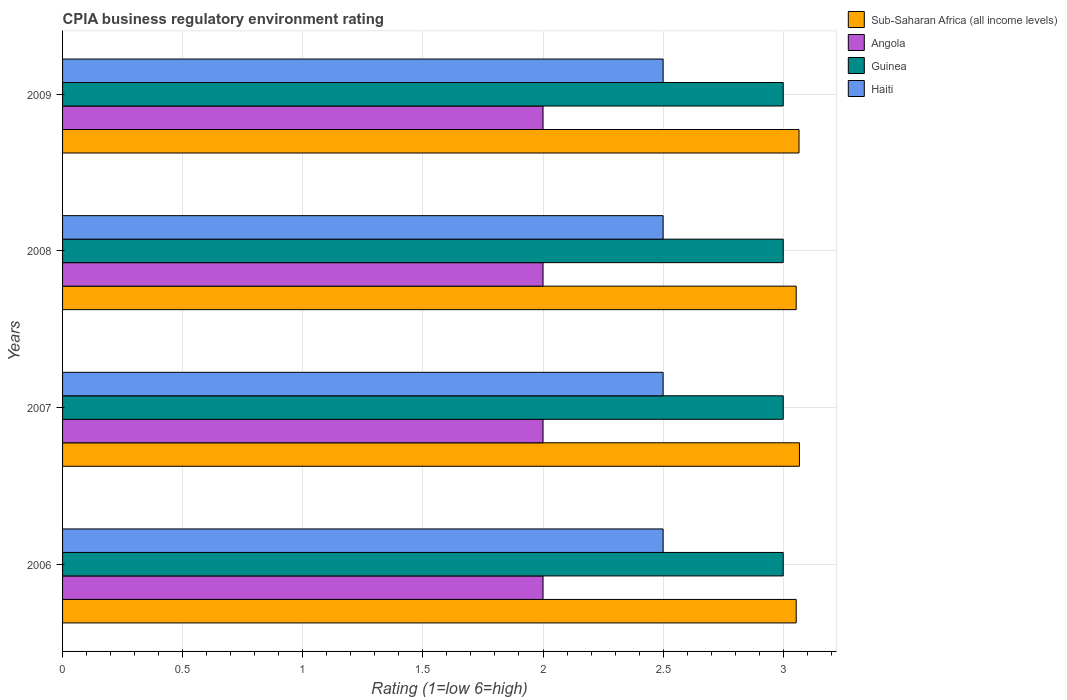Are the number of bars per tick equal to the number of legend labels?
Provide a succinct answer. Yes. How many bars are there on the 3rd tick from the top?
Ensure brevity in your answer.  4. How many bars are there on the 1st tick from the bottom?
Your answer should be very brief. 4. What is the CPIA rating in Guinea in 2006?
Provide a short and direct response. 3. Across all years, what is the minimum CPIA rating in Sub-Saharan Africa (all income levels)?
Your response must be concise. 3.05. In which year was the CPIA rating in Angola minimum?
Keep it short and to the point. 2006. What is the total CPIA rating in Sub-Saharan Africa (all income levels) in the graph?
Your answer should be compact. 12.24. What is the average CPIA rating in Guinea per year?
Provide a short and direct response. 3. In the year 2008, what is the difference between the CPIA rating in Haiti and CPIA rating in Angola?
Provide a short and direct response. 0.5. In how many years, is the CPIA rating in Sub-Saharan Africa (all income levels) greater than 2 ?
Provide a short and direct response. 4. What is the ratio of the CPIA rating in Guinea in 2008 to that in 2009?
Make the answer very short. 1. What is the difference between the highest and the second highest CPIA rating in Haiti?
Offer a very short reply. 0. In how many years, is the CPIA rating in Guinea greater than the average CPIA rating in Guinea taken over all years?
Make the answer very short. 0. Is the sum of the CPIA rating in Guinea in 2006 and 2008 greater than the maximum CPIA rating in Angola across all years?
Offer a terse response. Yes. Is it the case that in every year, the sum of the CPIA rating in Angola and CPIA rating in Guinea is greater than the sum of CPIA rating in Sub-Saharan Africa (all income levels) and CPIA rating in Haiti?
Provide a short and direct response. Yes. What does the 1st bar from the top in 2006 represents?
Ensure brevity in your answer.  Haiti. What does the 3rd bar from the bottom in 2006 represents?
Keep it short and to the point. Guinea. Are all the bars in the graph horizontal?
Provide a succinct answer. Yes. How many years are there in the graph?
Offer a terse response. 4. Are the values on the major ticks of X-axis written in scientific E-notation?
Your answer should be very brief. No. Does the graph contain any zero values?
Offer a very short reply. No. Does the graph contain grids?
Give a very brief answer. Yes. What is the title of the graph?
Your answer should be compact. CPIA business regulatory environment rating. What is the label or title of the X-axis?
Keep it short and to the point. Rating (1=low 6=high). What is the label or title of the Y-axis?
Make the answer very short. Years. What is the Rating (1=low 6=high) of Sub-Saharan Africa (all income levels) in 2006?
Keep it short and to the point. 3.05. What is the Rating (1=low 6=high) of Angola in 2006?
Give a very brief answer. 2. What is the Rating (1=low 6=high) in Guinea in 2006?
Your answer should be compact. 3. What is the Rating (1=low 6=high) of Sub-Saharan Africa (all income levels) in 2007?
Your response must be concise. 3.07. What is the Rating (1=low 6=high) of Angola in 2007?
Your answer should be compact. 2. What is the Rating (1=low 6=high) in Guinea in 2007?
Your response must be concise. 3. What is the Rating (1=low 6=high) in Sub-Saharan Africa (all income levels) in 2008?
Your answer should be very brief. 3.05. What is the Rating (1=low 6=high) in Guinea in 2008?
Offer a very short reply. 3. What is the Rating (1=low 6=high) in Sub-Saharan Africa (all income levels) in 2009?
Make the answer very short. 3.07. What is the Rating (1=low 6=high) in Guinea in 2009?
Give a very brief answer. 3. Across all years, what is the maximum Rating (1=low 6=high) in Sub-Saharan Africa (all income levels)?
Make the answer very short. 3.07. Across all years, what is the maximum Rating (1=low 6=high) in Angola?
Your answer should be very brief. 2. Across all years, what is the maximum Rating (1=low 6=high) of Haiti?
Offer a terse response. 2.5. Across all years, what is the minimum Rating (1=low 6=high) of Sub-Saharan Africa (all income levels)?
Provide a succinct answer. 3.05. Across all years, what is the minimum Rating (1=low 6=high) of Angola?
Ensure brevity in your answer.  2. Across all years, what is the minimum Rating (1=low 6=high) of Guinea?
Offer a very short reply. 3. What is the total Rating (1=low 6=high) of Sub-Saharan Africa (all income levels) in the graph?
Your answer should be compact. 12.24. What is the total Rating (1=low 6=high) of Angola in the graph?
Your answer should be very brief. 8. What is the total Rating (1=low 6=high) in Guinea in the graph?
Offer a terse response. 12. What is the total Rating (1=low 6=high) in Haiti in the graph?
Ensure brevity in your answer.  10. What is the difference between the Rating (1=low 6=high) in Sub-Saharan Africa (all income levels) in 2006 and that in 2007?
Your answer should be compact. -0.01. What is the difference between the Rating (1=low 6=high) in Angola in 2006 and that in 2007?
Offer a terse response. 0. What is the difference between the Rating (1=low 6=high) of Guinea in 2006 and that in 2007?
Your answer should be very brief. 0. What is the difference between the Rating (1=low 6=high) in Haiti in 2006 and that in 2007?
Provide a short and direct response. 0. What is the difference between the Rating (1=low 6=high) in Sub-Saharan Africa (all income levels) in 2006 and that in 2008?
Make the answer very short. 0. What is the difference between the Rating (1=low 6=high) of Guinea in 2006 and that in 2008?
Your response must be concise. 0. What is the difference between the Rating (1=low 6=high) of Sub-Saharan Africa (all income levels) in 2006 and that in 2009?
Your answer should be compact. -0.01. What is the difference between the Rating (1=low 6=high) in Guinea in 2006 and that in 2009?
Provide a short and direct response. 0. What is the difference between the Rating (1=low 6=high) in Sub-Saharan Africa (all income levels) in 2007 and that in 2008?
Provide a short and direct response. 0.01. What is the difference between the Rating (1=low 6=high) in Angola in 2007 and that in 2008?
Offer a very short reply. 0. What is the difference between the Rating (1=low 6=high) in Haiti in 2007 and that in 2008?
Ensure brevity in your answer.  0. What is the difference between the Rating (1=low 6=high) of Sub-Saharan Africa (all income levels) in 2007 and that in 2009?
Ensure brevity in your answer.  0. What is the difference between the Rating (1=low 6=high) in Sub-Saharan Africa (all income levels) in 2008 and that in 2009?
Your answer should be compact. -0.01. What is the difference between the Rating (1=low 6=high) of Angola in 2008 and that in 2009?
Give a very brief answer. 0. What is the difference between the Rating (1=low 6=high) in Guinea in 2008 and that in 2009?
Provide a short and direct response. 0. What is the difference between the Rating (1=low 6=high) of Haiti in 2008 and that in 2009?
Make the answer very short. 0. What is the difference between the Rating (1=low 6=high) in Sub-Saharan Africa (all income levels) in 2006 and the Rating (1=low 6=high) in Angola in 2007?
Your answer should be very brief. 1.05. What is the difference between the Rating (1=low 6=high) in Sub-Saharan Africa (all income levels) in 2006 and the Rating (1=low 6=high) in Guinea in 2007?
Your answer should be compact. 0.05. What is the difference between the Rating (1=low 6=high) of Sub-Saharan Africa (all income levels) in 2006 and the Rating (1=low 6=high) of Haiti in 2007?
Your answer should be very brief. 0.55. What is the difference between the Rating (1=low 6=high) in Angola in 2006 and the Rating (1=low 6=high) in Guinea in 2007?
Your answer should be very brief. -1. What is the difference between the Rating (1=low 6=high) in Guinea in 2006 and the Rating (1=low 6=high) in Haiti in 2007?
Your answer should be compact. 0.5. What is the difference between the Rating (1=low 6=high) in Sub-Saharan Africa (all income levels) in 2006 and the Rating (1=low 6=high) in Angola in 2008?
Provide a succinct answer. 1.05. What is the difference between the Rating (1=low 6=high) in Sub-Saharan Africa (all income levels) in 2006 and the Rating (1=low 6=high) in Guinea in 2008?
Ensure brevity in your answer.  0.05. What is the difference between the Rating (1=low 6=high) in Sub-Saharan Africa (all income levels) in 2006 and the Rating (1=low 6=high) in Haiti in 2008?
Provide a succinct answer. 0.55. What is the difference between the Rating (1=low 6=high) of Angola in 2006 and the Rating (1=low 6=high) of Guinea in 2008?
Your response must be concise. -1. What is the difference between the Rating (1=low 6=high) in Sub-Saharan Africa (all income levels) in 2006 and the Rating (1=low 6=high) in Angola in 2009?
Provide a succinct answer. 1.05. What is the difference between the Rating (1=low 6=high) of Sub-Saharan Africa (all income levels) in 2006 and the Rating (1=low 6=high) of Guinea in 2009?
Your answer should be compact. 0.05. What is the difference between the Rating (1=low 6=high) in Sub-Saharan Africa (all income levels) in 2006 and the Rating (1=low 6=high) in Haiti in 2009?
Make the answer very short. 0.55. What is the difference between the Rating (1=low 6=high) of Sub-Saharan Africa (all income levels) in 2007 and the Rating (1=low 6=high) of Angola in 2008?
Your response must be concise. 1.07. What is the difference between the Rating (1=low 6=high) of Sub-Saharan Africa (all income levels) in 2007 and the Rating (1=low 6=high) of Guinea in 2008?
Keep it short and to the point. 0.07. What is the difference between the Rating (1=low 6=high) in Sub-Saharan Africa (all income levels) in 2007 and the Rating (1=low 6=high) in Haiti in 2008?
Ensure brevity in your answer.  0.57. What is the difference between the Rating (1=low 6=high) in Sub-Saharan Africa (all income levels) in 2007 and the Rating (1=low 6=high) in Angola in 2009?
Give a very brief answer. 1.07. What is the difference between the Rating (1=low 6=high) in Sub-Saharan Africa (all income levels) in 2007 and the Rating (1=low 6=high) in Guinea in 2009?
Your response must be concise. 0.07. What is the difference between the Rating (1=low 6=high) of Sub-Saharan Africa (all income levels) in 2007 and the Rating (1=low 6=high) of Haiti in 2009?
Your answer should be compact. 0.57. What is the difference between the Rating (1=low 6=high) of Angola in 2007 and the Rating (1=low 6=high) of Haiti in 2009?
Provide a succinct answer. -0.5. What is the difference between the Rating (1=low 6=high) of Guinea in 2007 and the Rating (1=low 6=high) of Haiti in 2009?
Offer a terse response. 0.5. What is the difference between the Rating (1=low 6=high) of Sub-Saharan Africa (all income levels) in 2008 and the Rating (1=low 6=high) of Angola in 2009?
Your answer should be compact. 1.05. What is the difference between the Rating (1=low 6=high) of Sub-Saharan Africa (all income levels) in 2008 and the Rating (1=low 6=high) of Guinea in 2009?
Your answer should be very brief. 0.05. What is the difference between the Rating (1=low 6=high) in Sub-Saharan Africa (all income levels) in 2008 and the Rating (1=low 6=high) in Haiti in 2009?
Offer a very short reply. 0.55. What is the difference between the Rating (1=low 6=high) of Angola in 2008 and the Rating (1=low 6=high) of Guinea in 2009?
Provide a succinct answer. -1. What is the difference between the Rating (1=low 6=high) in Guinea in 2008 and the Rating (1=low 6=high) in Haiti in 2009?
Offer a very short reply. 0.5. What is the average Rating (1=low 6=high) in Sub-Saharan Africa (all income levels) per year?
Your response must be concise. 3.06. What is the average Rating (1=low 6=high) of Guinea per year?
Offer a terse response. 3. In the year 2006, what is the difference between the Rating (1=low 6=high) in Sub-Saharan Africa (all income levels) and Rating (1=low 6=high) in Angola?
Ensure brevity in your answer.  1.05. In the year 2006, what is the difference between the Rating (1=low 6=high) of Sub-Saharan Africa (all income levels) and Rating (1=low 6=high) of Guinea?
Provide a short and direct response. 0.05. In the year 2006, what is the difference between the Rating (1=low 6=high) in Sub-Saharan Africa (all income levels) and Rating (1=low 6=high) in Haiti?
Provide a succinct answer. 0.55. In the year 2006, what is the difference between the Rating (1=low 6=high) of Angola and Rating (1=low 6=high) of Guinea?
Make the answer very short. -1. In the year 2006, what is the difference between the Rating (1=low 6=high) in Guinea and Rating (1=low 6=high) in Haiti?
Your answer should be very brief. 0.5. In the year 2007, what is the difference between the Rating (1=low 6=high) in Sub-Saharan Africa (all income levels) and Rating (1=low 6=high) in Angola?
Offer a very short reply. 1.07. In the year 2007, what is the difference between the Rating (1=low 6=high) in Sub-Saharan Africa (all income levels) and Rating (1=low 6=high) in Guinea?
Give a very brief answer. 0.07. In the year 2007, what is the difference between the Rating (1=low 6=high) of Sub-Saharan Africa (all income levels) and Rating (1=low 6=high) of Haiti?
Give a very brief answer. 0.57. In the year 2008, what is the difference between the Rating (1=low 6=high) in Sub-Saharan Africa (all income levels) and Rating (1=low 6=high) in Angola?
Your answer should be very brief. 1.05. In the year 2008, what is the difference between the Rating (1=low 6=high) in Sub-Saharan Africa (all income levels) and Rating (1=low 6=high) in Guinea?
Provide a succinct answer. 0.05. In the year 2008, what is the difference between the Rating (1=low 6=high) in Sub-Saharan Africa (all income levels) and Rating (1=low 6=high) in Haiti?
Make the answer very short. 0.55. In the year 2008, what is the difference between the Rating (1=low 6=high) in Angola and Rating (1=low 6=high) in Guinea?
Your response must be concise. -1. In the year 2008, what is the difference between the Rating (1=low 6=high) of Angola and Rating (1=low 6=high) of Haiti?
Offer a terse response. -0.5. In the year 2008, what is the difference between the Rating (1=low 6=high) of Guinea and Rating (1=low 6=high) of Haiti?
Offer a very short reply. 0.5. In the year 2009, what is the difference between the Rating (1=low 6=high) in Sub-Saharan Africa (all income levels) and Rating (1=low 6=high) in Angola?
Your answer should be compact. 1.07. In the year 2009, what is the difference between the Rating (1=low 6=high) of Sub-Saharan Africa (all income levels) and Rating (1=low 6=high) of Guinea?
Your answer should be very brief. 0.07. In the year 2009, what is the difference between the Rating (1=low 6=high) of Sub-Saharan Africa (all income levels) and Rating (1=low 6=high) of Haiti?
Offer a very short reply. 0.57. In the year 2009, what is the difference between the Rating (1=low 6=high) in Angola and Rating (1=low 6=high) in Guinea?
Ensure brevity in your answer.  -1. In the year 2009, what is the difference between the Rating (1=low 6=high) in Angola and Rating (1=low 6=high) in Haiti?
Ensure brevity in your answer.  -0.5. What is the ratio of the Rating (1=low 6=high) of Guinea in 2006 to that in 2007?
Offer a very short reply. 1. What is the ratio of the Rating (1=low 6=high) of Haiti in 2006 to that in 2007?
Keep it short and to the point. 1. What is the ratio of the Rating (1=low 6=high) in Sub-Saharan Africa (all income levels) in 2006 to that in 2008?
Make the answer very short. 1. What is the ratio of the Rating (1=low 6=high) of Haiti in 2006 to that in 2008?
Provide a short and direct response. 1. What is the ratio of the Rating (1=low 6=high) of Sub-Saharan Africa (all income levels) in 2007 to that in 2008?
Your answer should be very brief. 1. What is the ratio of the Rating (1=low 6=high) in Angola in 2007 to that in 2008?
Keep it short and to the point. 1. What is the ratio of the Rating (1=low 6=high) in Guinea in 2007 to that in 2008?
Give a very brief answer. 1. What is the ratio of the Rating (1=low 6=high) of Sub-Saharan Africa (all income levels) in 2007 to that in 2009?
Provide a short and direct response. 1. What is the ratio of the Rating (1=low 6=high) in Angola in 2008 to that in 2009?
Make the answer very short. 1. What is the ratio of the Rating (1=low 6=high) in Guinea in 2008 to that in 2009?
Keep it short and to the point. 1. What is the difference between the highest and the second highest Rating (1=low 6=high) of Sub-Saharan Africa (all income levels)?
Keep it short and to the point. 0. What is the difference between the highest and the second highest Rating (1=low 6=high) of Haiti?
Provide a short and direct response. 0. What is the difference between the highest and the lowest Rating (1=low 6=high) of Sub-Saharan Africa (all income levels)?
Provide a short and direct response. 0.01. What is the difference between the highest and the lowest Rating (1=low 6=high) of Angola?
Keep it short and to the point. 0. What is the difference between the highest and the lowest Rating (1=low 6=high) of Haiti?
Your answer should be very brief. 0. 